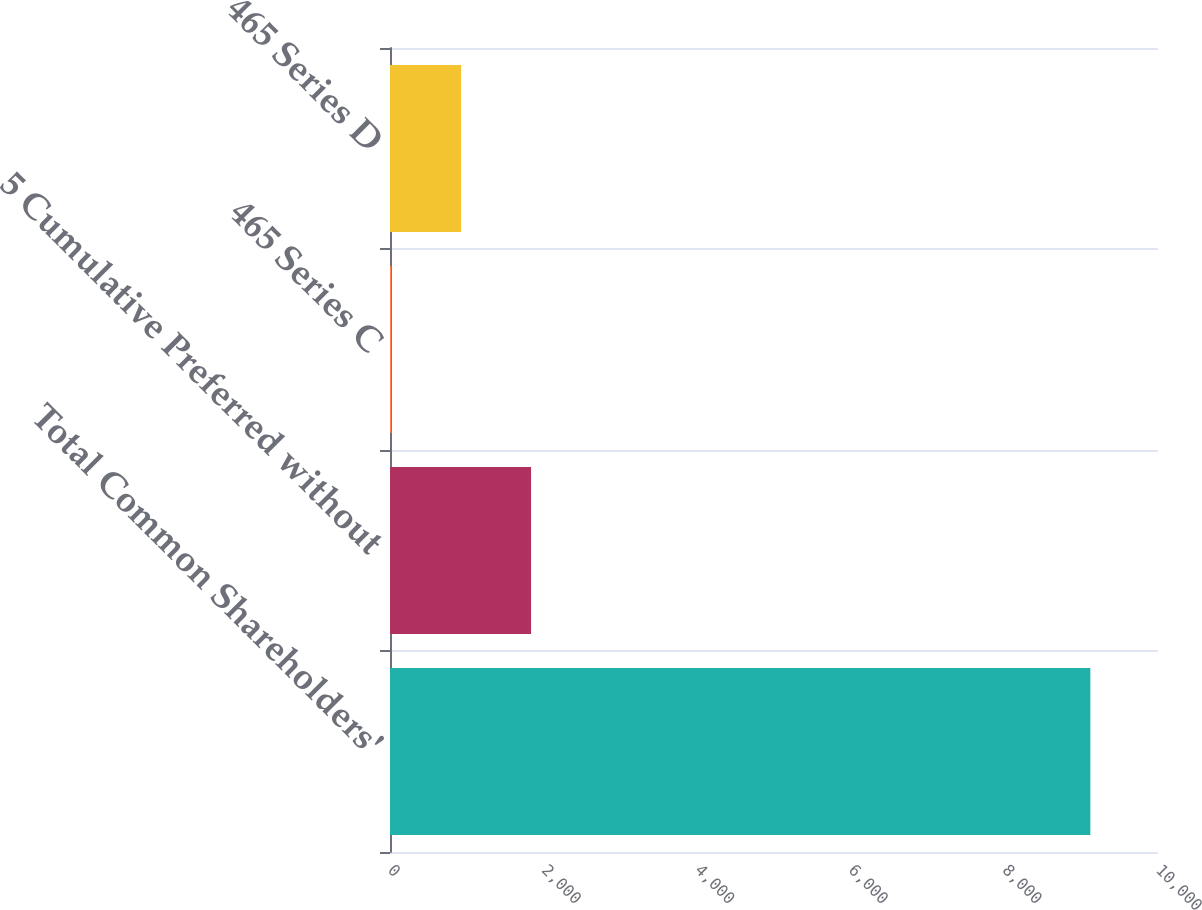Convert chart. <chart><loc_0><loc_0><loc_500><loc_500><bar_chart><fcel>Total Common Shareholders'<fcel>5 Cumulative Preferred without<fcel>465 Series C<fcel>465 Series D<nl><fcel>9119<fcel>1836.6<fcel>16<fcel>926.3<nl></chart> 